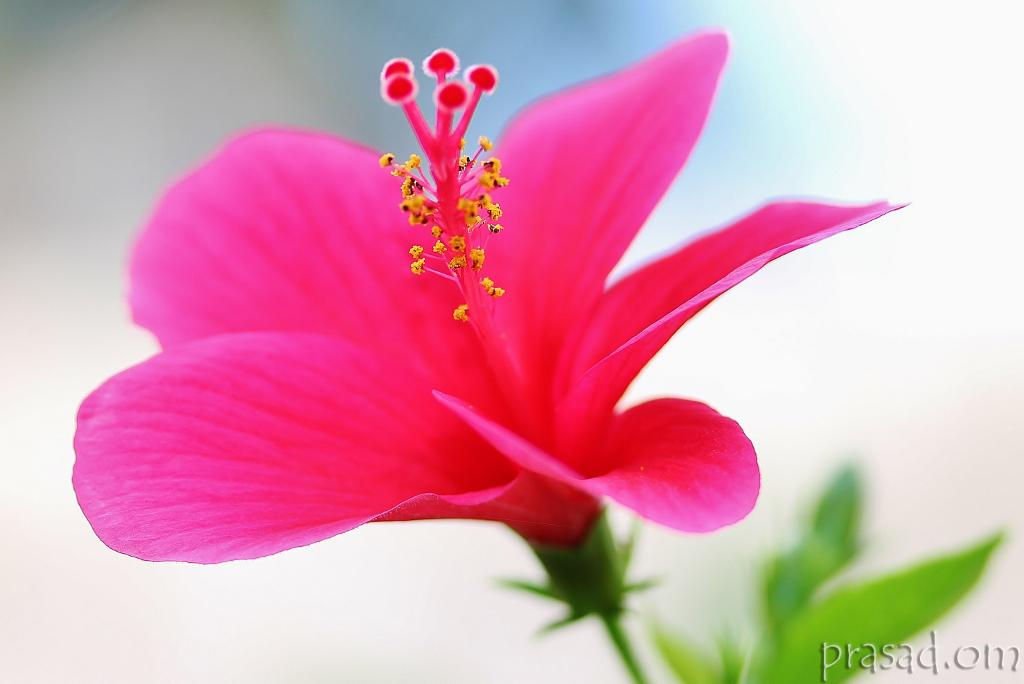What is the main subject of the image? The main subject of the image is a flower. What colors can be seen on the flower? The flower has two colors: pink and yellow. What color are the leaves of the flower? The leaves of the flower are green. Is there any text present in the image? Yes, there is text written on the image. Can you see a beetle crawling on the flower in the image? No, there is no beetle present in the image. Is there a ghost visible in the image? No, there is no ghost present in the image. 